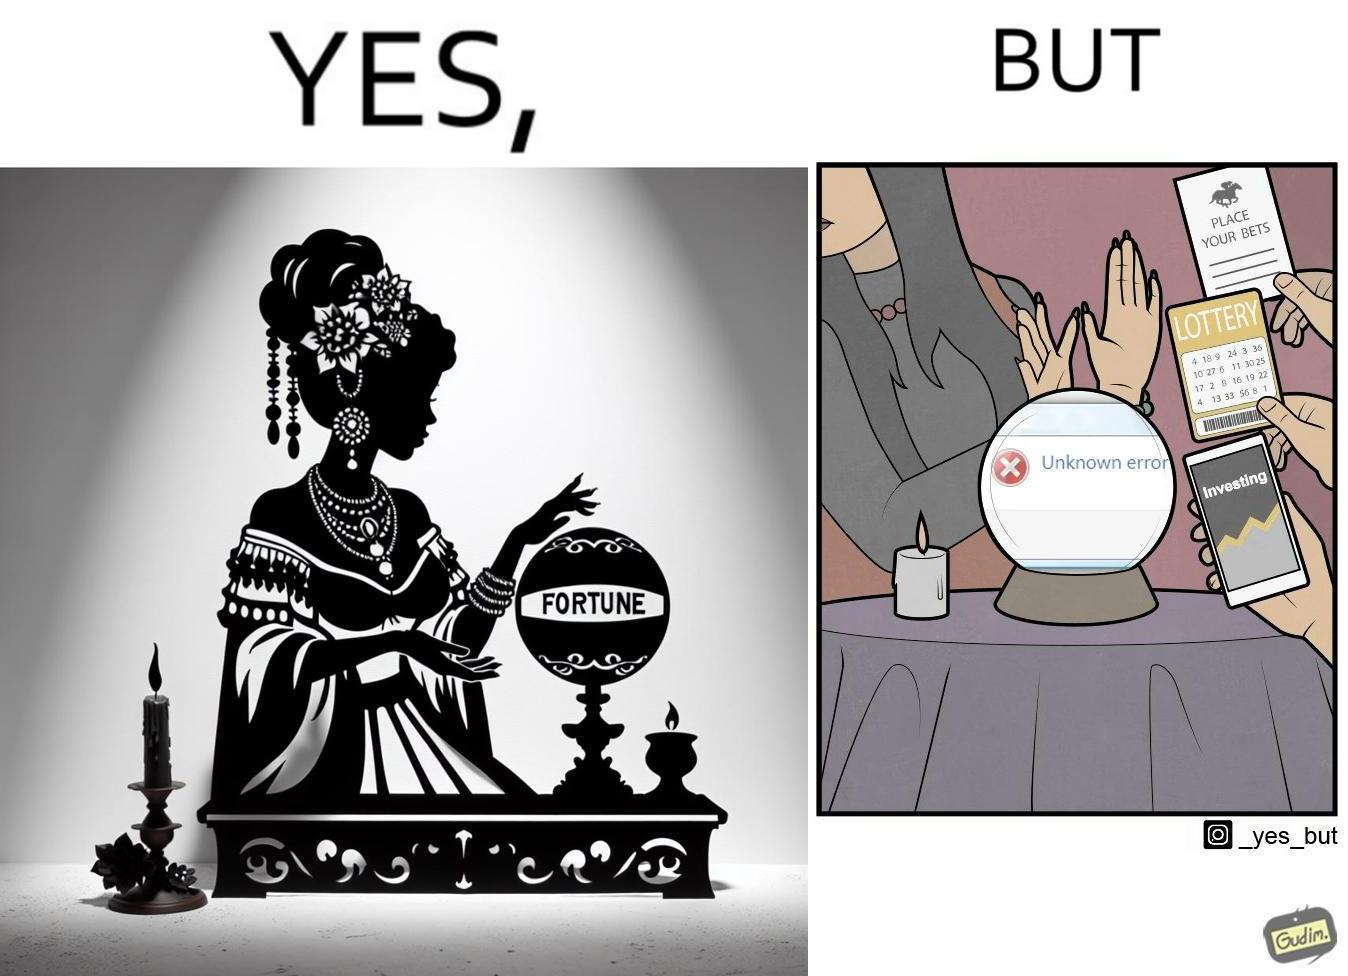Describe the contrast between the left and right parts of this image. In the left part of the image: a woman dressed up as fortune teller with a candle and a fortune teller globe with "FORTUNE" written on it In the right part of the image: a woman rejecting peoples' request to predict on finance, bets and lottery as giving some "Unknown error" 